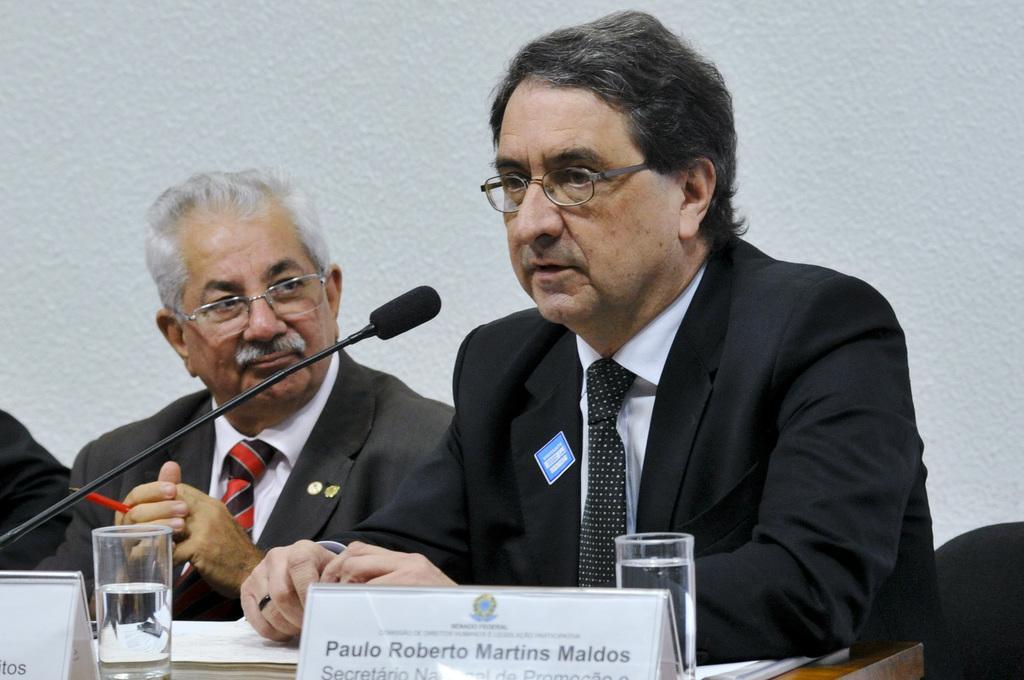Describe this image in one or two sentences. This image consists of two persons wearing suits along with the ties. In the background, there is a wall in white color. In the front, we can see a table on which there are name plates, glasses, and a mic. 